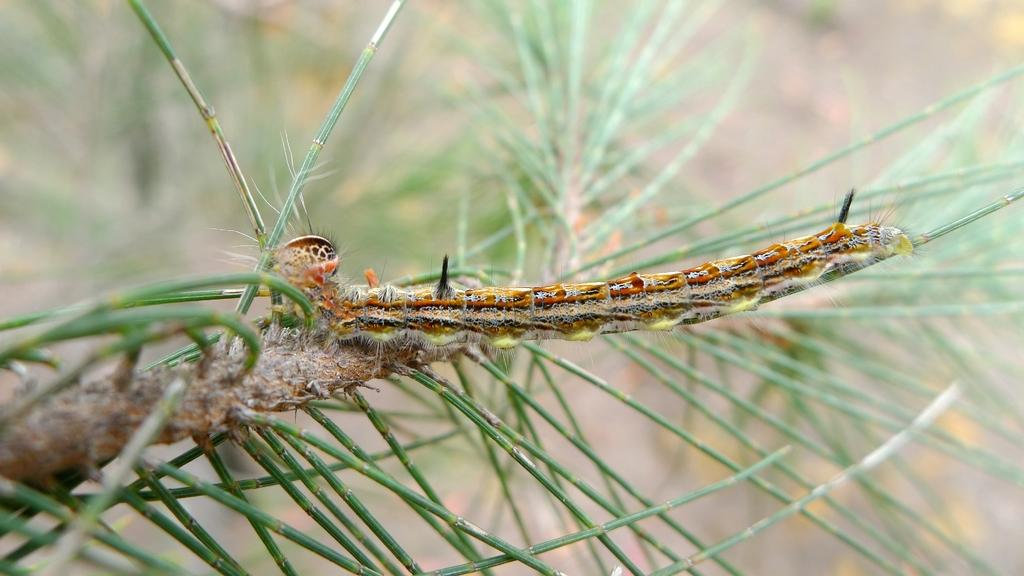What is the main object in the image? There is a branch in the image. What else can be seen on the branch? There are twigs in the image. Are there any living creatures visible on the branch? Yes, there appears to be a caterpillar in the image. How would you describe the background of the image? The background of the image is blurred. What type of berry can be seen growing on the branch in the image? There is no berry visible on the branch in the image. 